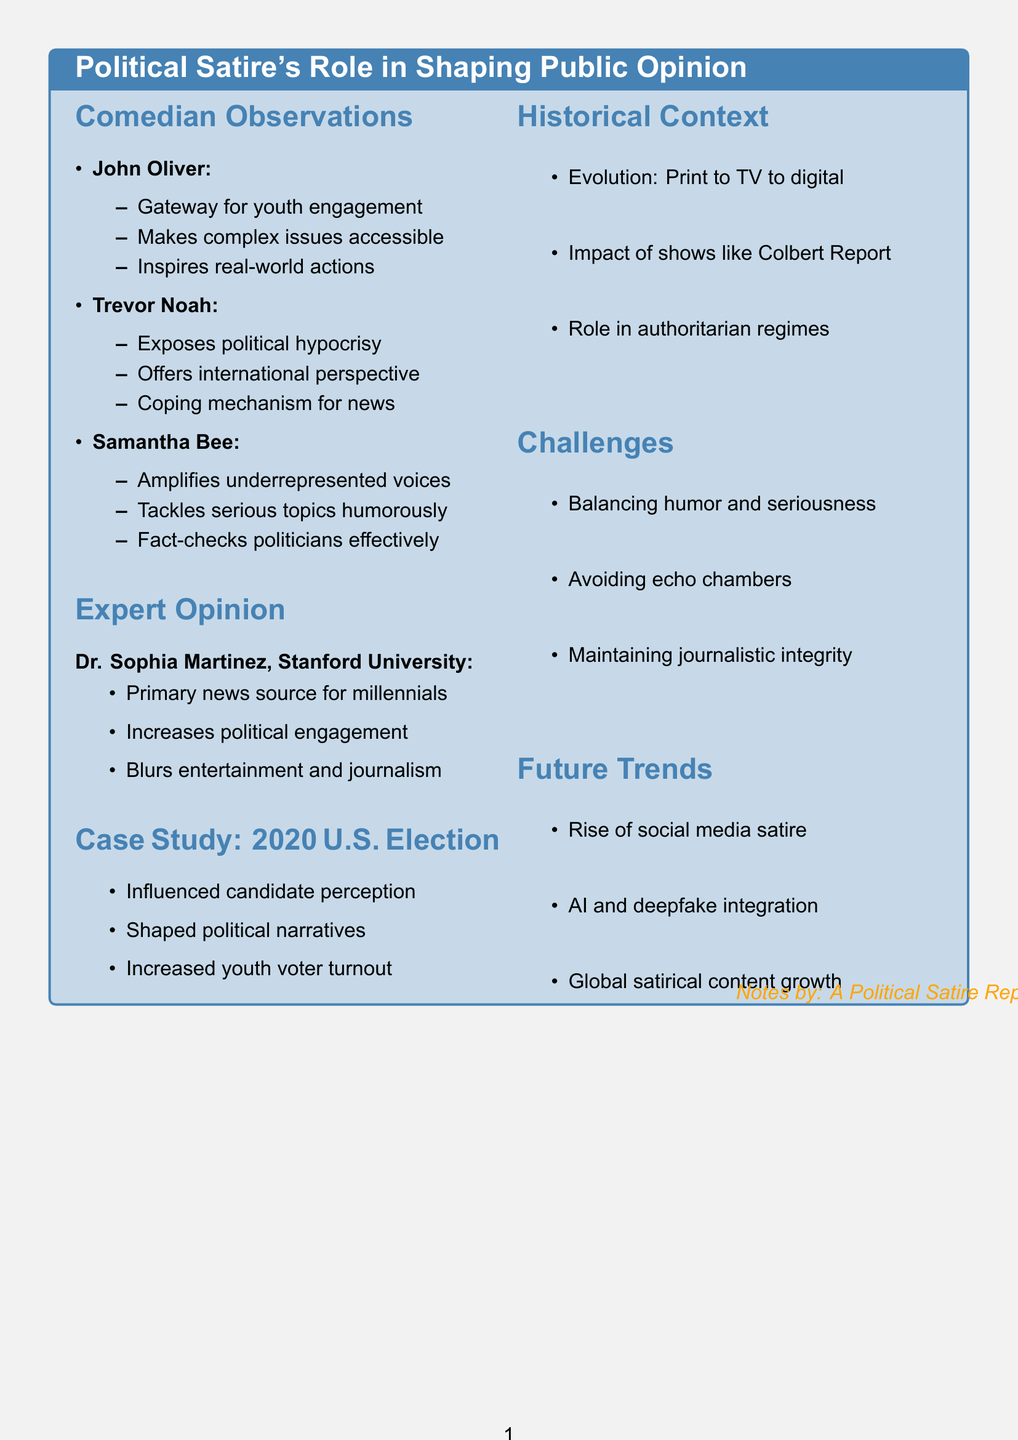What is the main topic of the document? The document discusses the role of political satire in influencing public opinion.
Answer: Political satire's role in shaping public opinion Who is the comedian that emphasizes youth engagement? The document notes John Oliver's observations specifically mentioning youth engagement.
Answer: John Oliver What show does Trevor Noah host? The document states that Trevor Noah hosts The Daily Show.
Answer: The Daily Show What is a challenge faced by political satire according to the document? The document lists balancing humor with serious issues as one of the challenges.
Answer: Balancing humor with serious issues Which university does Dr. Sophia Martinez represent? The document identifies Dr. Sophia Martinez as being from Stanford University.
Answer: Stanford University What event did late-night shows influence during the document's case study? The case study in the document focuses on the 2020 U.S. Presidential Election.
Answer: 2020 U.S. Presidential Election What is a future trend mentioned in the document related to political satire? The document mentions the rise of social media platforms for bite-sized political satire as a future trend.
Answer: Rise of social media platforms for bite-sized political satire Which comedian is known for amplifying underrepresented voices? The document indicates that Samantha Bee is known for this in her comedic work.
Answer: Samantha Bee What does political satire do to serious topics according to Samantha Bee's observations? The document states that Full Frontal uses humor to tackle serious topics.
Answer: Uses humor to tackle serious topics 